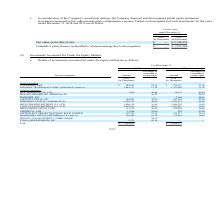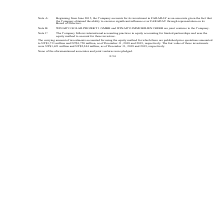According to United Micro Electronics's financial document, What accounting practices is used by the company in equity accounting? international accounting practices. The document states: "Note C: The Company follows international accounting practices in equity accounting for limited partnerships and uses the equity method to account for..." Also, What was the price quotation for investments as of 31 December 2018? According to the financial document, NT$1,733 million. The relevant text states: "there are published price quotations amounted to NT$1,733 million and NT$1,750 million, as of December 31, 2018 and 2019, respectively. The fair value of these inves..." Also, What was the fair value for investments as of 31 December 2018 ? According to the financial document, NT$1,621 million. The relevant text states: "ctively. The fair value of these investments were NT$1,621 million and NT$2,244 million, as of December 31, 2018 and 2019, respectively...." Also, can you calculate: What is the average amount of investments of listed companies in 2018? To answer this question, I need to perform calculations using the financial data. The calculation is: (249,663+1,483,111) / 2, which equals 866387 (in thousands). This is based on the information: "21.90 FARADAY TECHNOLOGY CORP. (FARADAY) (Note A) 1,483,111 13.78 1,473,028 13.78 Unlisted companies MTIC HOLDINGS PTE. LTD. 3,026 45.44 18,157 45.44 WINAICO I (In Thousands) Listed companies CLIENTRO..." The key data points involved are: 1,483,111, 249,663. Also, can you calculate: What is the average amount of investments of listed companies in 2019? To answer this question, I need to perform calculations using the financial data. The calculation is: (276,515+1,473,028) / 2, which equals 874771.5 (in thousands). This is based on the information: "CHNOLOGY CORP. (FARADAY) (Note A) 1,483,111 13.78 1,473,028 13.78 Unlisted companies MTIC HOLDINGS PTE. LTD. 3,026 45.44 18,157 45.44 WINAICO IMMOBILIEN GMBH ( isted companies CLIENTRON CORP. $ 249,66..." The key data points involved are: 1,473,028, 276,515. Also, can you calculate: What is the average Percentage of ownership or voting rights of listed companies in 2019? To answer this question, I need to perform calculations using the financial data. The calculation is: (21.9+13.78) / 2, which equals 17.84 (percentage). This is based on the information: "ompanies CLIENTRON CORP. $ 249,663 22.39 $ 276,515 21.90 FARADAY TECHNOLOGY CORP. (FARADAY) (Note A) 1,483,111 13.78 1,473,028 13.78 Unlisted companies MTI DAY TECHNOLOGY CORP. (FARADAY) (Note A) 1,48..." The key data points involved are: 13.78, 21.9. 